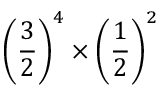Convert formula to latex. <formula><loc_0><loc_0><loc_500><loc_500>\left ( { \frac { 3 } { 2 } } \right ) ^ { 4 } \times \left ( { \frac { 1 } { 2 } } \right ) ^ { 2 }</formula> 